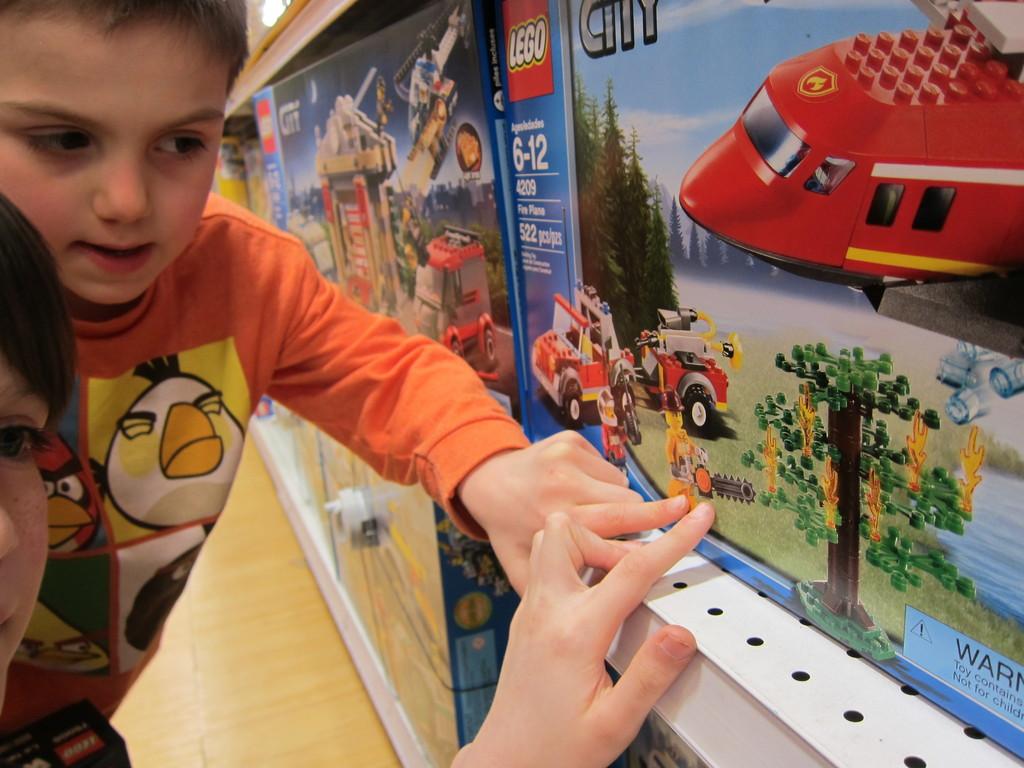Who manufactures these toys?
Provide a succinct answer. Lego. This is cat?
Provide a short and direct response. No. 